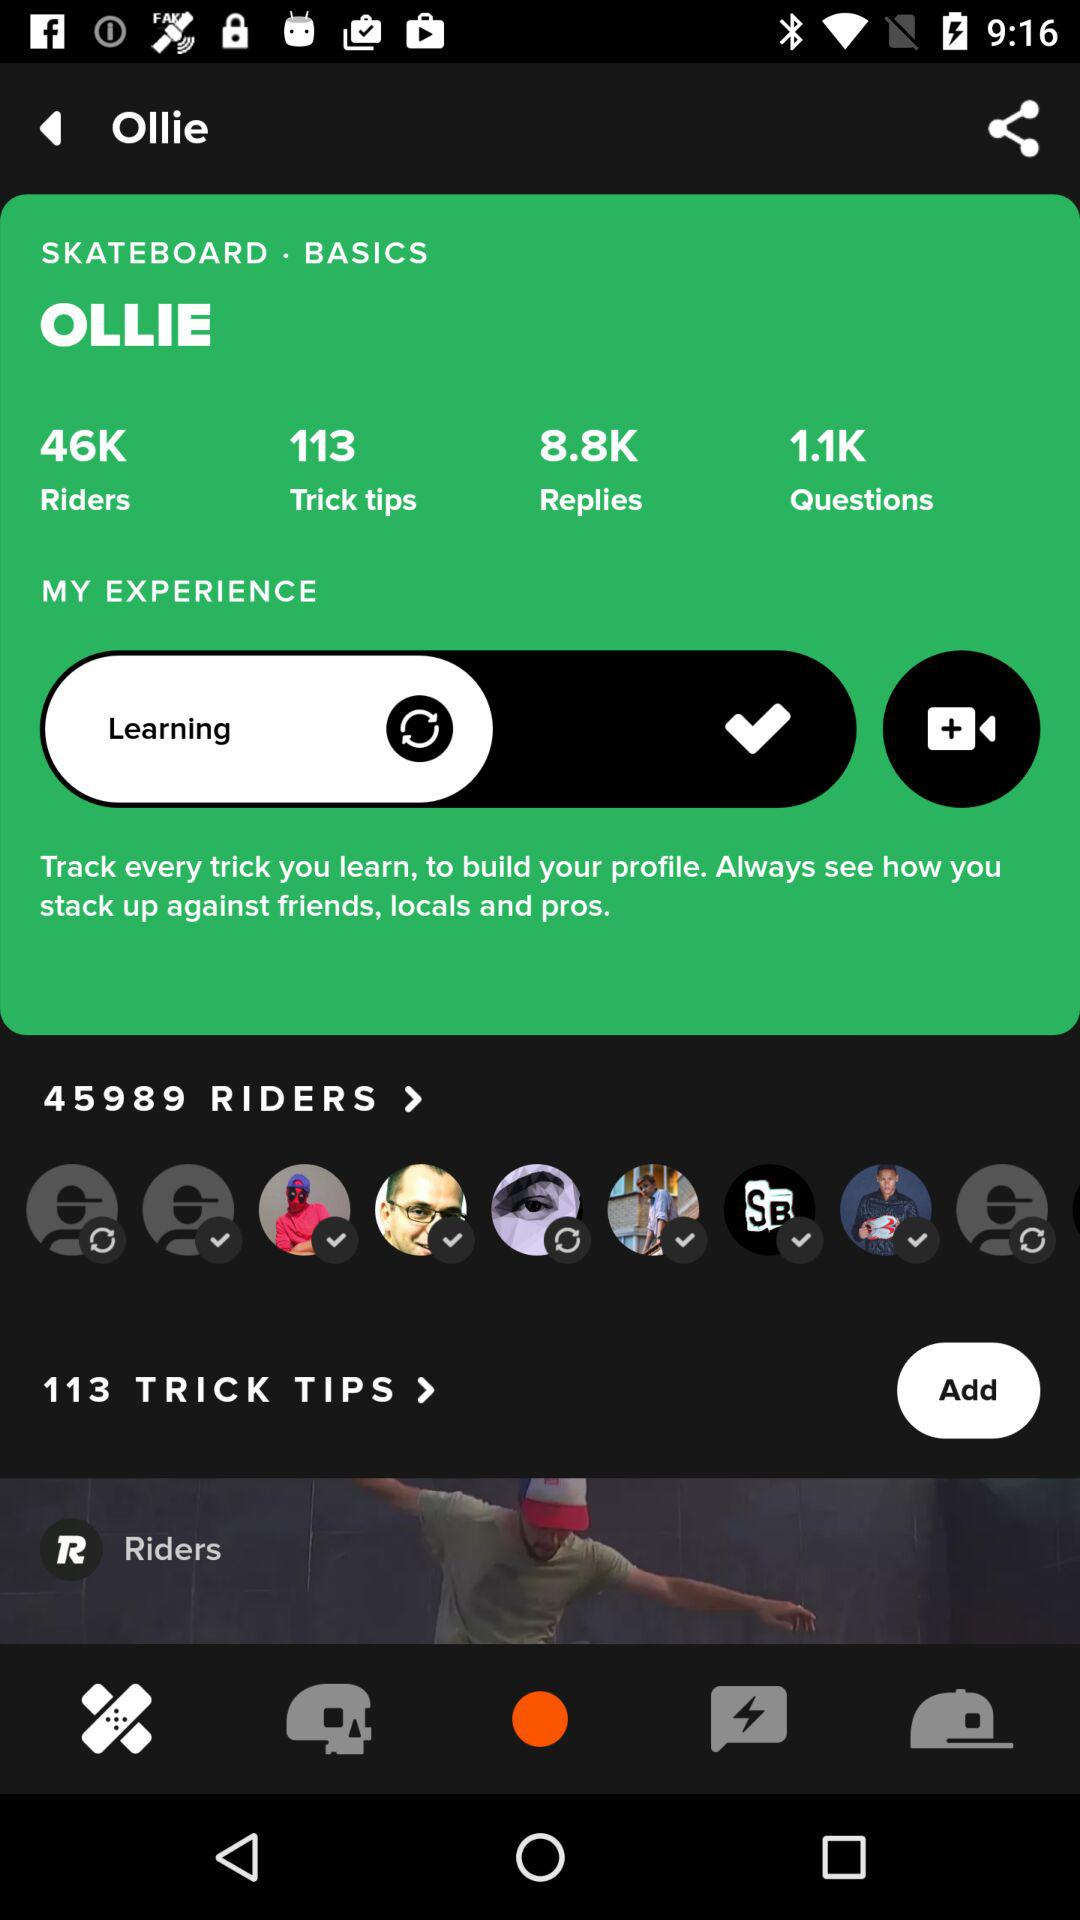How many questions in total are there? There are 1.1K questions. 